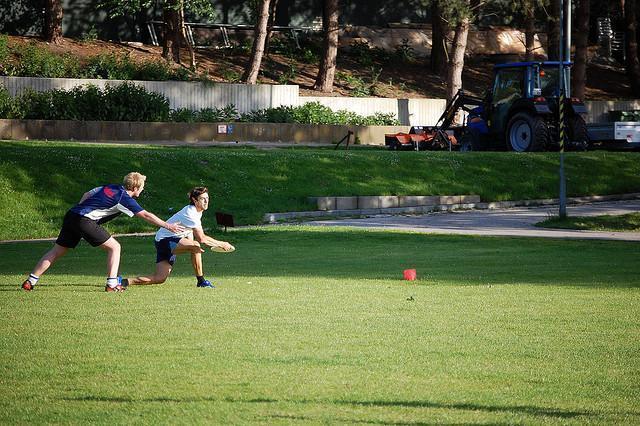How many people are visible?
Give a very brief answer. 2. How many horses are there?
Give a very brief answer. 0. 